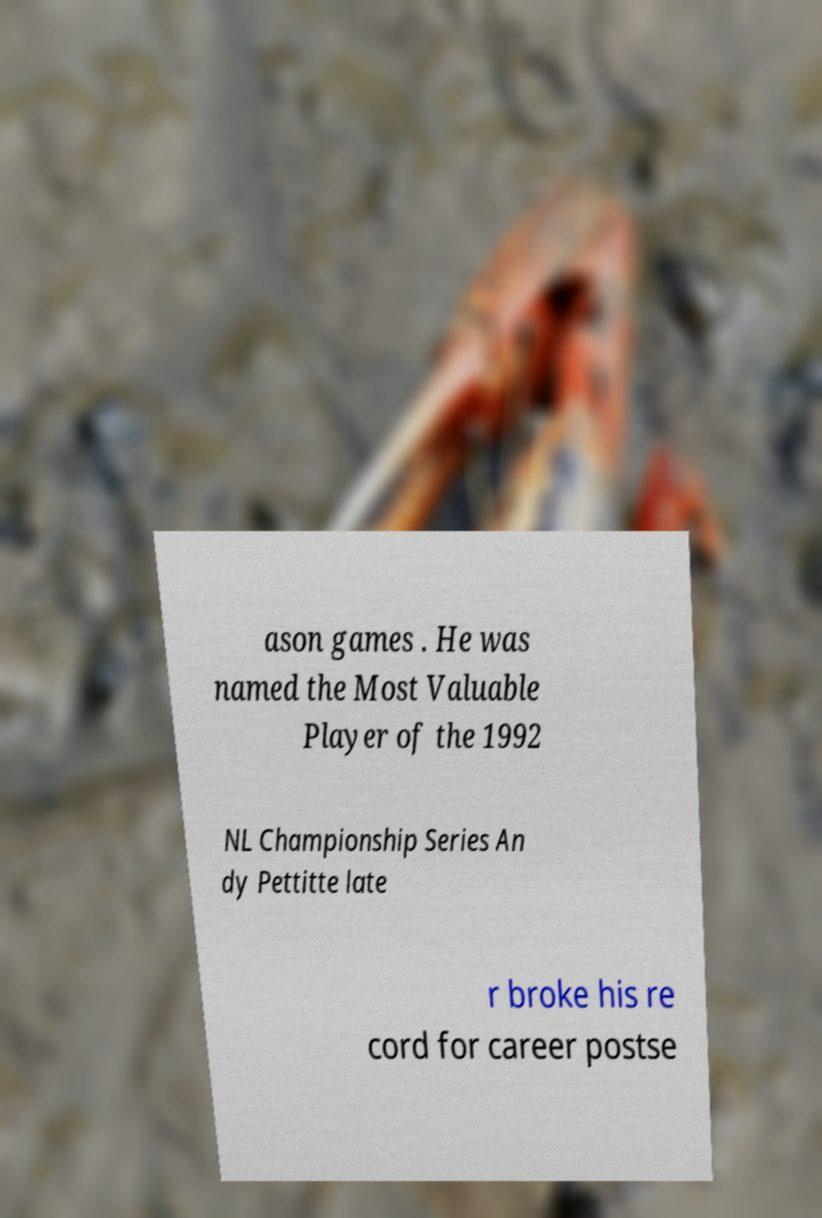Can you read and provide the text displayed in the image?This photo seems to have some interesting text. Can you extract and type it out for me? ason games . He was named the Most Valuable Player of the 1992 NL Championship Series An dy Pettitte late r broke his re cord for career postse 